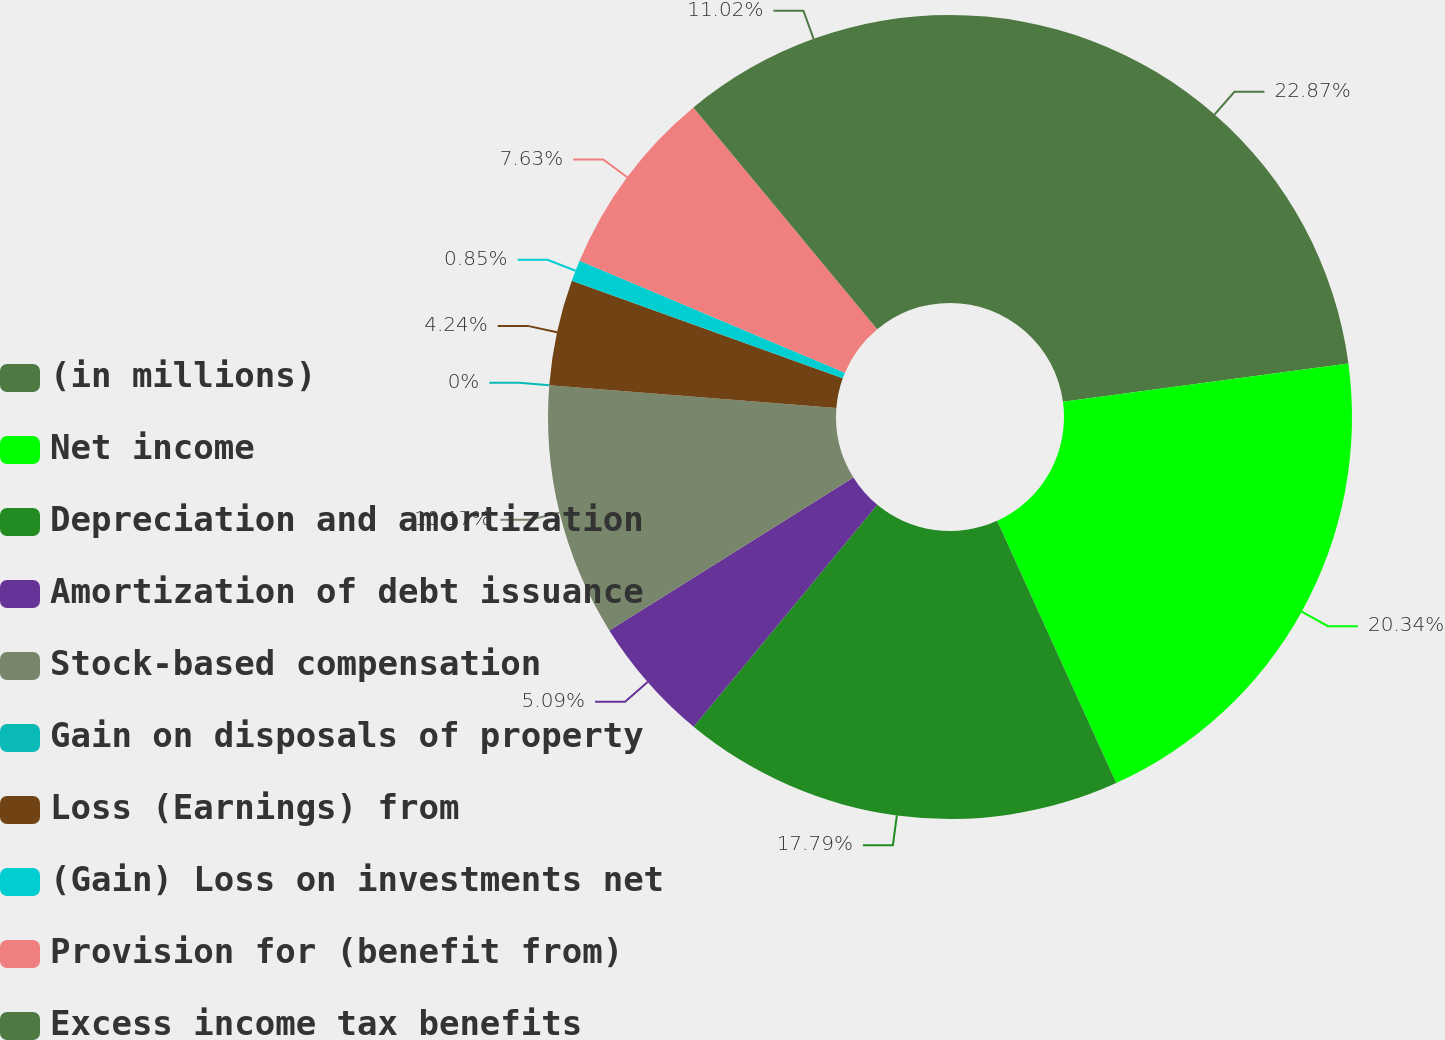Convert chart. <chart><loc_0><loc_0><loc_500><loc_500><pie_chart><fcel>(in millions)<fcel>Net income<fcel>Depreciation and amortization<fcel>Amortization of debt issuance<fcel>Stock-based compensation<fcel>Gain on disposals of property<fcel>Loss (Earnings) from<fcel>(Gain) Loss on investments net<fcel>Provision for (benefit from)<fcel>Excess income tax benefits<nl><fcel>22.88%<fcel>20.34%<fcel>17.79%<fcel>5.09%<fcel>10.17%<fcel>0.0%<fcel>4.24%<fcel>0.85%<fcel>7.63%<fcel>11.02%<nl></chart> 